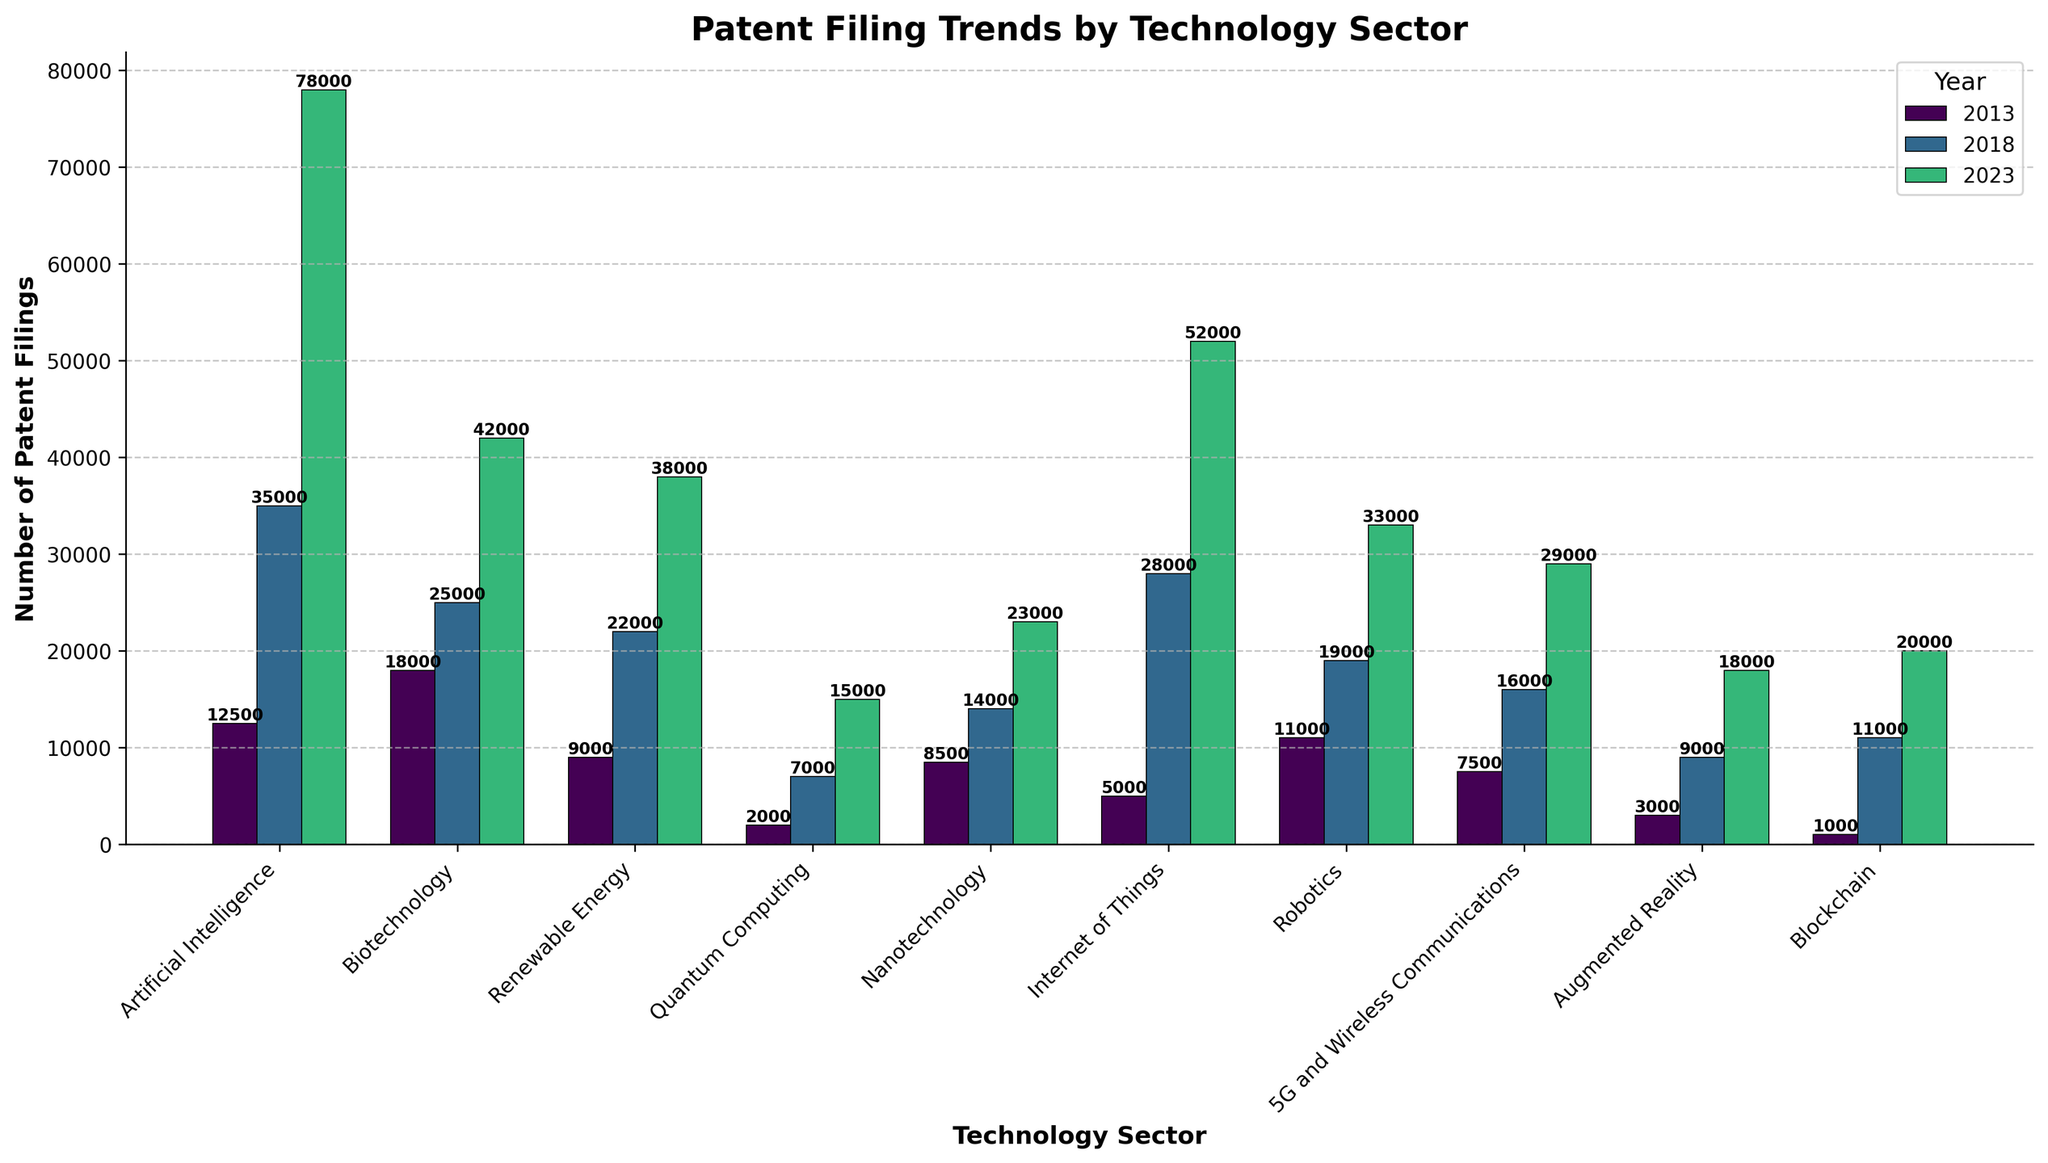What's the highest number of patent filings in 2023? Identify the year 2023 and compare the height of the bars across all sectors. The highest bar in 2023 corresponds to the AI sector with 78,000 patent filings.
Answer: 78,000 Which technology sector had the largest increase in patent filings from 2013 to 2023? Calculate the difference in patent filings between 2013 and 2023 for all sectors. The AI sector shows the largest increase from 12,500 in 2013 to 78,000 in 2023, a difference of 65,500.
Answer: Artificial Intelligence Compare the number of patent filings in Blockchain and Quantum Computing in 2023. Which one is higher, and by how much? In 2023, Blockchain has 20,000 and Quantum Computing has 15,000 filings. The difference is 20,000 - 15,000 = 5,000, with Blockchain having more filings.
Answer: Blockchain by 5,000 What is the average number of patent filings for the Robotics sector across all three years? Add the number of filings for Robotics in 2013, 2018, and 2023 and divide by 3: (11,000 + 19,000 + 33,000) / 3 = 63,000 / 3 = 21,000
Answer: 21,000 Considering Renewable Energy and Biotechnology in 2018, which sector had fewer patent filings and by what margin? Compare the 2018 filings: Renewable Energy (22,000) and Biotechnology (25,000). Difference = 25,000 - 22,000 = 3,000.
Answer: Renewable Energy by 3,000 Which sector had the least change in the number of patent filings between 2013 and 2023? Calculate the changes for each sector: Artificial Intelligence (65,500), Biotechnology (24,000), Renewable Energy (29,000), Quantum Computing (13,000), Nanotechnology (14,500), Internet of Things (47,000), Robotics (22,000), 5G and Wireless Communications (21,500), Augmented Reality (15,000), Blockchain (19,000). The smallest change is in Quantum Computing (13,000).
Answer: Quantum Computing What's the total number of patent filings across all sectors in 2018? Sum the filings in 2018 for each sector: 35,000 + 25,000 + 22,000 + 7,000 + 14,000 + 28,000 + 19,000 + 16,000 + 9,000 + 11,000 = 186,000
Answer: 186,000 Identify the sector with the second-lowest number of patent filings in 2013 and its value. Compare values in 2013: Blockchain (1,000), Quantum Computing (2,000), Augmented Reality (3,000), Internet of Things (5,000), 5G and Wireless Communications (7,500), Nanotechnology (8,500), Renewable Energy (9,000), Robotics (11,000), Artificial Intelligence (12,500), Biotechnology (18,000). The second-lowest is Quantum Computing with 2,000.
Answer: Quantum Computing with 2,000 For the Artificial Intelligence sector, what was the percentage increase in patent filings from 2013 to 2023? Calculate the percentage increase using the formula: (New Value - Old Value) / Old Value * 100%: (78,000 - 12,500) / 12,500 * 100% = 65,500 / 12,500 * 100% ≈ 524%.
Answer: 524% 